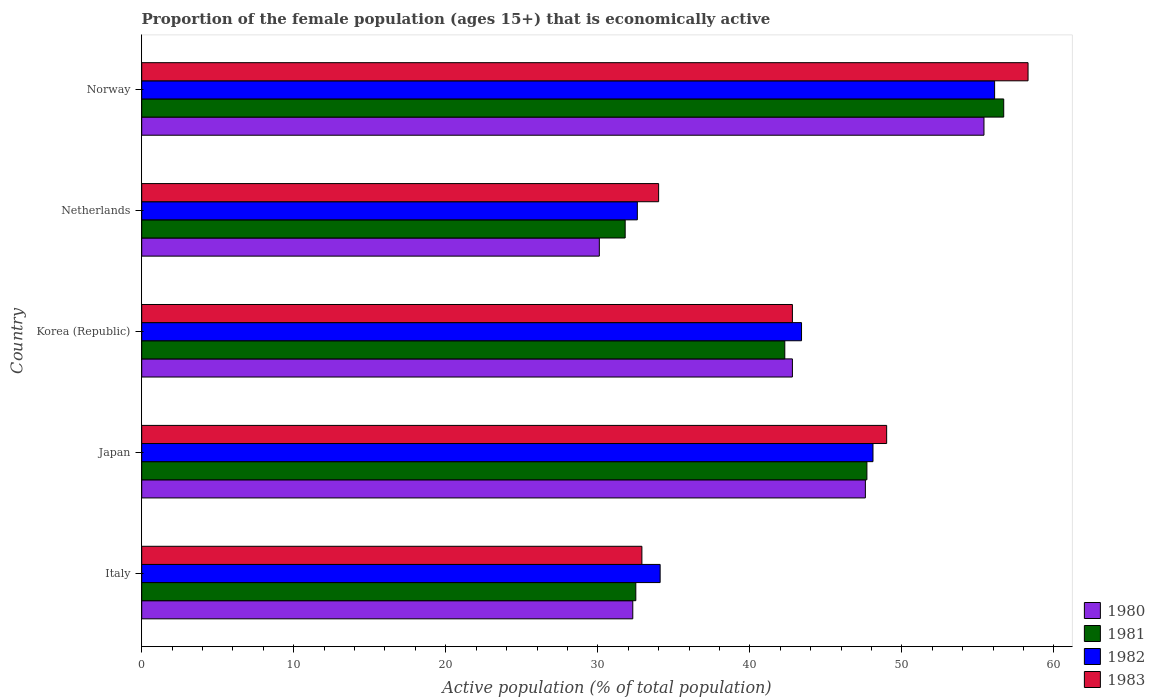How many groups of bars are there?
Provide a succinct answer. 5. Are the number of bars per tick equal to the number of legend labels?
Provide a succinct answer. Yes. How many bars are there on the 4th tick from the top?
Your answer should be very brief. 4. In how many cases, is the number of bars for a given country not equal to the number of legend labels?
Make the answer very short. 0. What is the proportion of the female population that is economically active in 1983 in Netherlands?
Ensure brevity in your answer.  34. Across all countries, what is the maximum proportion of the female population that is economically active in 1982?
Make the answer very short. 56.1. Across all countries, what is the minimum proportion of the female population that is economically active in 1983?
Your answer should be compact. 32.9. In which country was the proportion of the female population that is economically active in 1982 maximum?
Provide a succinct answer. Norway. In which country was the proportion of the female population that is economically active in 1983 minimum?
Make the answer very short. Italy. What is the total proportion of the female population that is economically active in 1981 in the graph?
Keep it short and to the point. 211. What is the difference between the proportion of the female population that is economically active in 1980 in Japan and that in Netherlands?
Provide a short and direct response. 17.5. What is the difference between the proportion of the female population that is economically active in 1983 in Italy and the proportion of the female population that is economically active in 1981 in Korea (Republic)?
Provide a succinct answer. -9.4. What is the average proportion of the female population that is economically active in 1983 per country?
Keep it short and to the point. 43.4. What is the difference between the proportion of the female population that is economically active in 1980 and proportion of the female population that is economically active in 1983 in Netherlands?
Offer a very short reply. -3.9. What is the ratio of the proportion of the female population that is economically active in 1983 in Italy to that in Netherlands?
Your answer should be compact. 0.97. Is the difference between the proportion of the female population that is economically active in 1980 in Korea (Republic) and Netherlands greater than the difference between the proportion of the female population that is economically active in 1983 in Korea (Republic) and Netherlands?
Your answer should be very brief. Yes. What is the difference between the highest and the second highest proportion of the female population that is economically active in 1981?
Make the answer very short. 9. What is the difference between the highest and the lowest proportion of the female population that is economically active in 1982?
Provide a short and direct response. 23.5. Is the sum of the proportion of the female population that is economically active in 1983 in Italy and Japan greater than the maximum proportion of the female population that is economically active in 1982 across all countries?
Ensure brevity in your answer.  Yes. Is it the case that in every country, the sum of the proportion of the female population that is economically active in 1982 and proportion of the female population that is economically active in 1980 is greater than the sum of proportion of the female population that is economically active in 1981 and proportion of the female population that is economically active in 1983?
Your answer should be compact. No. What does the 1st bar from the top in Netherlands represents?
Offer a terse response. 1983. What does the 2nd bar from the bottom in Netherlands represents?
Your answer should be very brief. 1981. Are all the bars in the graph horizontal?
Your answer should be very brief. Yes. What is the difference between two consecutive major ticks on the X-axis?
Your answer should be very brief. 10. Are the values on the major ticks of X-axis written in scientific E-notation?
Provide a succinct answer. No. Does the graph contain any zero values?
Your answer should be very brief. No. Where does the legend appear in the graph?
Offer a terse response. Bottom right. How many legend labels are there?
Your response must be concise. 4. How are the legend labels stacked?
Keep it short and to the point. Vertical. What is the title of the graph?
Your answer should be very brief. Proportion of the female population (ages 15+) that is economically active. What is the label or title of the X-axis?
Make the answer very short. Active population (% of total population). What is the Active population (% of total population) of 1980 in Italy?
Ensure brevity in your answer.  32.3. What is the Active population (% of total population) in 1981 in Italy?
Offer a terse response. 32.5. What is the Active population (% of total population) of 1982 in Italy?
Make the answer very short. 34.1. What is the Active population (% of total population) of 1983 in Italy?
Your answer should be compact. 32.9. What is the Active population (% of total population) of 1980 in Japan?
Provide a short and direct response. 47.6. What is the Active population (% of total population) of 1981 in Japan?
Your answer should be very brief. 47.7. What is the Active population (% of total population) in 1982 in Japan?
Offer a very short reply. 48.1. What is the Active population (% of total population) of 1980 in Korea (Republic)?
Provide a succinct answer. 42.8. What is the Active population (% of total population) in 1981 in Korea (Republic)?
Offer a very short reply. 42.3. What is the Active population (% of total population) of 1982 in Korea (Republic)?
Offer a very short reply. 43.4. What is the Active population (% of total population) in 1983 in Korea (Republic)?
Ensure brevity in your answer.  42.8. What is the Active population (% of total population) in 1980 in Netherlands?
Offer a terse response. 30.1. What is the Active population (% of total population) in 1981 in Netherlands?
Offer a very short reply. 31.8. What is the Active population (% of total population) in 1982 in Netherlands?
Offer a very short reply. 32.6. What is the Active population (% of total population) in 1980 in Norway?
Keep it short and to the point. 55.4. What is the Active population (% of total population) of 1981 in Norway?
Your answer should be very brief. 56.7. What is the Active population (% of total population) in 1982 in Norway?
Ensure brevity in your answer.  56.1. What is the Active population (% of total population) in 1983 in Norway?
Your answer should be very brief. 58.3. Across all countries, what is the maximum Active population (% of total population) of 1980?
Keep it short and to the point. 55.4. Across all countries, what is the maximum Active population (% of total population) of 1981?
Keep it short and to the point. 56.7. Across all countries, what is the maximum Active population (% of total population) of 1982?
Offer a very short reply. 56.1. Across all countries, what is the maximum Active population (% of total population) of 1983?
Provide a succinct answer. 58.3. Across all countries, what is the minimum Active population (% of total population) of 1980?
Offer a terse response. 30.1. Across all countries, what is the minimum Active population (% of total population) of 1981?
Offer a terse response. 31.8. Across all countries, what is the minimum Active population (% of total population) in 1982?
Your response must be concise. 32.6. Across all countries, what is the minimum Active population (% of total population) in 1983?
Offer a very short reply. 32.9. What is the total Active population (% of total population) in 1980 in the graph?
Provide a short and direct response. 208.2. What is the total Active population (% of total population) in 1981 in the graph?
Keep it short and to the point. 211. What is the total Active population (% of total population) in 1982 in the graph?
Provide a succinct answer. 214.3. What is the total Active population (% of total population) of 1983 in the graph?
Provide a succinct answer. 217. What is the difference between the Active population (% of total population) in 1980 in Italy and that in Japan?
Provide a short and direct response. -15.3. What is the difference between the Active population (% of total population) of 1981 in Italy and that in Japan?
Offer a very short reply. -15.2. What is the difference between the Active population (% of total population) in 1982 in Italy and that in Japan?
Give a very brief answer. -14. What is the difference between the Active population (% of total population) in 1983 in Italy and that in Japan?
Your answer should be very brief. -16.1. What is the difference between the Active population (% of total population) in 1980 in Italy and that in Korea (Republic)?
Give a very brief answer. -10.5. What is the difference between the Active population (% of total population) in 1983 in Italy and that in Korea (Republic)?
Ensure brevity in your answer.  -9.9. What is the difference between the Active population (% of total population) in 1980 in Italy and that in Netherlands?
Your answer should be very brief. 2.2. What is the difference between the Active population (% of total population) of 1981 in Italy and that in Netherlands?
Provide a short and direct response. 0.7. What is the difference between the Active population (% of total population) of 1982 in Italy and that in Netherlands?
Provide a short and direct response. 1.5. What is the difference between the Active population (% of total population) of 1983 in Italy and that in Netherlands?
Offer a terse response. -1.1. What is the difference between the Active population (% of total population) of 1980 in Italy and that in Norway?
Your answer should be very brief. -23.1. What is the difference between the Active population (% of total population) of 1981 in Italy and that in Norway?
Keep it short and to the point. -24.2. What is the difference between the Active population (% of total population) of 1983 in Italy and that in Norway?
Your answer should be compact. -25.4. What is the difference between the Active population (% of total population) of 1981 in Japan and that in Korea (Republic)?
Your answer should be compact. 5.4. What is the difference between the Active population (% of total population) in 1983 in Japan and that in Korea (Republic)?
Ensure brevity in your answer.  6.2. What is the difference between the Active population (% of total population) in 1980 in Japan and that in Netherlands?
Your answer should be compact. 17.5. What is the difference between the Active population (% of total population) of 1981 in Japan and that in Netherlands?
Your answer should be compact. 15.9. What is the difference between the Active population (% of total population) of 1982 in Japan and that in Netherlands?
Give a very brief answer. 15.5. What is the difference between the Active population (% of total population) in 1983 in Japan and that in Netherlands?
Your response must be concise. 15. What is the difference between the Active population (% of total population) in 1980 in Japan and that in Norway?
Your answer should be compact. -7.8. What is the difference between the Active population (% of total population) of 1981 in Japan and that in Norway?
Give a very brief answer. -9. What is the difference between the Active population (% of total population) of 1982 in Japan and that in Norway?
Keep it short and to the point. -8. What is the difference between the Active population (% of total population) in 1982 in Korea (Republic) and that in Netherlands?
Ensure brevity in your answer.  10.8. What is the difference between the Active population (% of total population) of 1983 in Korea (Republic) and that in Netherlands?
Your response must be concise. 8.8. What is the difference between the Active population (% of total population) of 1981 in Korea (Republic) and that in Norway?
Ensure brevity in your answer.  -14.4. What is the difference between the Active population (% of total population) in 1982 in Korea (Republic) and that in Norway?
Offer a terse response. -12.7. What is the difference between the Active population (% of total population) of 1983 in Korea (Republic) and that in Norway?
Provide a succinct answer. -15.5. What is the difference between the Active population (% of total population) in 1980 in Netherlands and that in Norway?
Your response must be concise. -25.3. What is the difference between the Active population (% of total population) in 1981 in Netherlands and that in Norway?
Offer a very short reply. -24.9. What is the difference between the Active population (% of total population) of 1982 in Netherlands and that in Norway?
Ensure brevity in your answer.  -23.5. What is the difference between the Active population (% of total population) in 1983 in Netherlands and that in Norway?
Offer a very short reply. -24.3. What is the difference between the Active population (% of total population) in 1980 in Italy and the Active population (% of total population) in 1981 in Japan?
Your response must be concise. -15.4. What is the difference between the Active population (% of total population) in 1980 in Italy and the Active population (% of total population) in 1982 in Japan?
Provide a succinct answer. -15.8. What is the difference between the Active population (% of total population) in 1980 in Italy and the Active population (% of total population) in 1983 in Japan?
Offer a terse response. -16.7. What is the difference between the Active population (% of total population) of 1981 in Italy and the Active population (% of total population) of 1982 in Japan?
Ensure brevity in your answer.  -15.6. What is the difference between the Active population (% of total population) in 1981 in Italy and the Active population (% of total population) in 1983 in Japan?
Keep it short and to the point. -16.5. What is the difference between the Active population (% of total population) in 1982 in Italy and the Active population (% of total population) in 1983 in Japan?
Give a very brief answer. -14.9. What is the difference between the Active population (% of total population) in 1980 in Italy and the Active population (% of total population) in 1981 in Korea (Republic)?
Keep it short and to the point. -10. What is the difference between the Active population (% of total population) of 1980 in Italy and the Active population (% of total population) of 1983 in Korea (Republic)?
Keep it short and to the point. -10.5. What is the difference between the Active population (% of total population) of 1980 in Italy and the Active population (% of total population) of 1982 in Netherlands?
Offer a terse response. -0.3. What is the difference between the Active population (% of total population) in 1980 in Italy and the Active population (% of total population) in 1983 in Netherlands?
Keep it short and to the point. -1.7. What is the difference between the Active population (% of total population) of 1981 in Italy and the Active population (% of total population) of 1982 in Netherlands?
Your response must be concise. -0.1. What is the difference between the Active population (% of total population) in 1980 in Italy and the Active population (% of total population) in 1981 in Norway?
Your answer should be very brief. -24.4. What is the difference between the Active population (% of total population) of 1980 in Italy and the Active population (% of total population) of 1982 in Norway?
Make the answer very short. -23.8. What is the difference between the Active population (% of total population) of 1980 in Italy and the Active population (% of total population) of 1983 in Norway?
Your response must be concise. -26. What is the difference between the Active population (% of total population) of 1981 in Italy and the Active population (% of total population) of 1982 in Norway?
Keep it short and to the point. -23.6. What is the difference between the Active population (% of total population) of 1981 in Italy and the Active population (% of total population) of 1983 in Norway?
Offer a terse response. -25.8. What is the difference between the Active population (% of total population) in 1982 in Italy and the Active population (% of total population) in 1983 in Norway?
Keep it short and to the point. -24.2. What is the difference between the Active population (% of total population) of 1980 in Japan and the Active population (% of total population) of 1981 in Korea (Republic)?
Ensure brevity in your answer.  5.3. What is the difference between the Active population (% of total population) in 1981 in Japan and the Active population (% of total population) in 1983 in Korea (Republic)?
Your response must be concise. 4.9. What is the difference between the Active population (% of total population) in 1980 in Japan and the Active population (% of total population) in 1982 in Netherlands?
Provide a succinct answer. 15. What is the difference between the Active population (% of total population) of 1980 in Japan and the Active population (% of total population) of 1981 in Norway?
Give a very brief answer. -9.1. What is the difference between the Active population (% of total population) in 1980 in Korea (Republic) and the Active population (% of total population) in 1981 in Netherlands?
Your answer should be very brief. 11. What is the difference between the Active population (% of total population) in 1981 in Korea (Republic) and the Active population (% of total population) in 1982 in Netherlands?
Keep it short and to the point. 9.7. What is the difference between the Active population (% of total population) in 1981 in Korea (Republic) and the Active population (% of total population) in 1983 in Netherlands?
Your response must be concise. 8.3. What is the difference between the Active population (% of total population) in 1982 in Korea (Republic) and the Active population (% of total population) in 1983 in Netherlands?
Give a very brief answer. 9.4. What is the difference between the Active population (% of total population) in 1980 in Korea (Republic) and the Active population (% of total population) in 1983 in Norway?
Your response must be concise. -15.5. What is the difference between the Active population (% of total population) in 1981 in Korea (Republic) and the Active population (% of total population) in 1982 in Norway?
Offer a terse response. -13.8. What is the difference between the Active population (% of total population) of 1981 in Korea (Republic) and the Active population (% of total population) of 1983 in Norway?
Make the answer very short. -16. What is the difference between the Active population (% of total population) in 1982 in Korea (Republic) and the Active population (% of total population) in 1983 in Norway?
Offer a very short reply. -14.9. What is the difference between the Active population (% of total population) of 1980 in Netherlands and the Active population (% of total population) of 1981 in Norway?
Your answer should be compact. -26.6. What is the difference between the Active population (% of total population) of 1980 in Netherlands and the Active population (% of total population) of 1983 in Norway?
Your answer should be compact. -28.2. What is the difference between the Active population (% of total population) of 1981 in Netherlands and the Active population (% of total population) of 1982 in Norway?
Your response must be concise. -24.3. What is the difference between the Active population (% of total population) of 1981 in Netherlands and the Active population (% of total population) of 1983 in Norway?
Your answer should be compact. -26.5. What is the difference between the Active population (% of total population) of 1982 in Netherlands and the Active population (% of total population) of 1983 in Norway?
Offer a terse response. -25.7. What is the average Active population (% of total population) in 1980 per country?
Your answer should be very brief. 41.64. What is the average Active population (% of total population) of 1981 per country?
Ensure brevity in your answer.  42.2. What is the average Active population (% of total population) in 1982 per country?
Offer a very short reply. 42.86. What is the average Active population (% of total population) of 1983 per country?
Your response must be concise. 43.4. What is the difference between the Active population (% of total population) of 1980 and Active population (% of total population) of 1981 in Italy?
Provide a succinct answer. -0.2. What is the difference between the Active population (% of total population) in 1980 and Active population (% of total population) in 1982 in Italy?
Ensure brevity in your answer.  -1.8. What is the difference between the Active population (% of total population) in 1980 and Active population (% of total population) in 1981 in Japan?
Your response must be concise. -0.1. What is the difference between the Active population (% of total population) of 1980 and Active population (% of total population) of 1983 in Japan?
Ensure brevity in your answer.  -1.4. What is the difference between the Active population (% of total population) of 1981 and Active population (% of total population) of 1982 in Japan?
Your answer should be compact. -0.4. What is the difference between the Active population (% of total population) in 1982 and Active population (% of total population) in 1983 in Japan?
Your response must be concise. -0.9. What is the difference between the Active population (% of total population) of 1980 and Active population (% of total population) of 1981 in Korea (Republic)?
Your answer should be very brief. 0.5. What is the difference between the Active population (% of total population) of 1981 and Active population (% of total population) of 1982 in Korea (Republic)?
Make the answer very short. -1.1. What is the difference between the Active population (% of total population) of 1981 and Active population (% of total population) of 1983 in Korea (Republic)?
Your answer should be very brief. -0.5. What is the difference between the Active population (% of total population) in 1982 and Active population (% of total population) in 1983 in Korea (Republic)?
Offer a very short reply. 0.6. What is the difference between the Active population (% of total population) of 1980 and Active population (% of total population) of 1981 in Netherlands?
Provide a short and direct response. -1.7. What is the difference between the Active population (% of total population) in 1980 and Active population (% of total population) in 1982 in Netherlands?
Make the answer very short. -2.5. What is the difference between the Active population (% of total population) of 1982 and Active population (% of total population) of 1983 in Netherlands?
Your answer should be very brief. -1.4. What is the difference between the Active population (% of total population) of 1980 and Active population (% of total population) of 1981 in Norway?
Provide a succinct answer. -1.3. What is the difference between the Active population (% of total population) in 1980 and Active population (% of total population) in 1982 in Norway?
Give a very brief answer. -0.7. What is the ratio of the Active population (% of total population) in 1980 in Italy to that in Japan?
Provide a succinct answer. 0.68. What is the ratio of the Active population (% of total population) of 1981 in Italy to that in Japan?
Give a very brief answer. 0.68. What is the ratio of the Active population (% of total population) of 1982 in Italy to that in Japan?
Your answer should be very brief. 0.71. What is the ratio of the Active population (% of total population) of 1983 in Italy to that in Japan?
Ensure brevity in your answer.  0.67. What is the ratio of the Active population (% of total population) in 1980 in Italy to that in Korea (Republic)?
Your answer should be compact. 0.75. What is the ratio of the Active population (% of total population) of 1981 in Italy to that in Korea (Republic)?
Your answer should be very brief. 0.77. What is the ratio of the Active population (% of total population) in 1982 in Italy to that in Korea (Republic)?
Your response must be concise. 0.79. What is the ratio of the Active population (% of total population) in 1983 in Italy to that in Korea (Republic)?
Keep it short and to the point. 0.77. What is the ratio of the Active population (% of total population) in 1980 in Italy to that in Netherlands?
Make the answer very short. 1.07. What is the ratio of the Active population (% of total population) of 1981 in Italy to that in Netherlands?
Provide a succinct answer. 1.02. What is the ratio of the Active population (% of total population) in 1982 in Italy to that in Netherlands?
Your answer should be compact. 1.05. What is the ratio of the Active population (% of total population) in 1983 in Italy to that in Netherlands?
Give a very brief answer. 0.97. What is the ratio of the Active population (% of total population) of 1980 in Italy to that in Norway?
Offer a very short reply. 0.58. What is the ratio of the Active population (% of total population) of 1981 in Italy to that in Norway?
Provide a succinct answer. 0.57. What is the ratio of the Active population (% of total population) in 1982 in Italy to that in Norway?
Ensure brevity in your answer.  0.61. What is the ratio of the Active population (% of total population) in 1983 in Italy to that in Norway?
Make the answer very short. 0.56. What is the ratio of the Active population (% of total population) of 1980 in Japan to that in Korea (Republic)?
Your answer should be very brief. 1.11. What is the ratio of the Active population (% of total population) in 1981 in Japan to that in Korea (Republic)?
Provide a short and direct response. 1.13. What is the ratio of the Active population (% of total population) of 1982 in Japan to that in Korea (Republic)?
Keep it short and to the point. 1.11. What is the ratio of the Active population (% of total population) of 1983 in Japan to that in Korea (Republic)?
Your answer should be very brief. 1.14. What is the ratio of the Active population (% of total population) in 1980 in Japan to that in Netherlands?
Give a very brief answer. 1.58. What is the ratio of the Active population (% of total population) of 1982 in Japan to that in Netherlands?
Offer a terse response. 1.48. What is the ratio of the Active population (% of total population) of 1983 in Japan to that in Netherlands?
Make the answer very short. 1.44. What is the ratio of the Active population (% of total population) in 1980 in Japan to that in Norway?
Make the answer very short. 0.86. What is the ratio of the Active population (% of total population) in 1981 in Japan to that in Norway?
Your answer should be very brief. 0.84. What is the ratio of the Active population (% of total population) in 1982 in Japan to that in Norway?
Offer a very short reply. 0.86. What is the ratio of the Active population (% of total population) in 1983 in Japan to that in Norway?
Offer a terse response. 0.84. What is the ratio of the Active population (% of total population) of 1980 in Korea (Republic) to that in Netherlands?
Offer a terse response. 1.42. What is the ratio of the Active population (% of total population) in 1981 in Korea (Republic) to that in Netherlands?
Make the answer very short. 1.33. What is the ratio of the Active population (% of total population) in 1982 in Korea (Republic) to that in Netherlands?
Your answer should be very brief. 1.33. What is the ratio of the Active population (% of total population) in 1983 in Korea (Republic) to that in Netherlands?
Provide a short and direct response. 1.26. What is the ratio of the Active population (% of total population) in 1980 in Korea (Republic) to that in Norway?
Your answer should be very brief. 0.77. What is the ratio of the Active population (% of total population) of 1981 in Korea (Republic) to that in Norway?
Provide a succinct answer. 0.75. What is the ratio of the Active population (% of total population) of 1982 in Korea (Republic) to that in Norway?
Offer a very short reply. 0.77. What is the ratio of the Active population (% of total population) in 1983 in Korea (Republic) to that in Norway?
Ensure brevity in your answer.  0.73. What is the ratio of the Active population (% of total population) in 1980 in Netherlands to that in Norway?
Keep it short and to the point. 0.54. What is the ratio of the Active population (% of total population) of 1981 in Netherlands to that in Norway?
Offer a very short reply. 0.56. What is the ratio of the Active population (% of total population) of 1982 in Netherlands to that in Norway?
Give a very brief answer. 0.58. What is the ratio of the Active population (% of total population) in 1983 in Netherlands to that in Norway?
Provide a succinct answer. 0.58. What is the difference between the highest and the second highest Active population (% of total population) in 1981?
Give a very brief answer. 9. What is the difference between the highest and the lowest Active population (% of total population) in 1980?
Provide a short and direct response. 25.3. What is the difference between the highest and the lowest Active population (% of total population) of 1981?
Ensure brevity in your answer.  24.9. What is the difference between the highest and the lowest Active population (% of total population) of 1982?
Your response must be concise. 23.5. What is the difference between the highest and the lowest Active population (% of total population) of 1983?
Give a very brief answer. 25.4. 